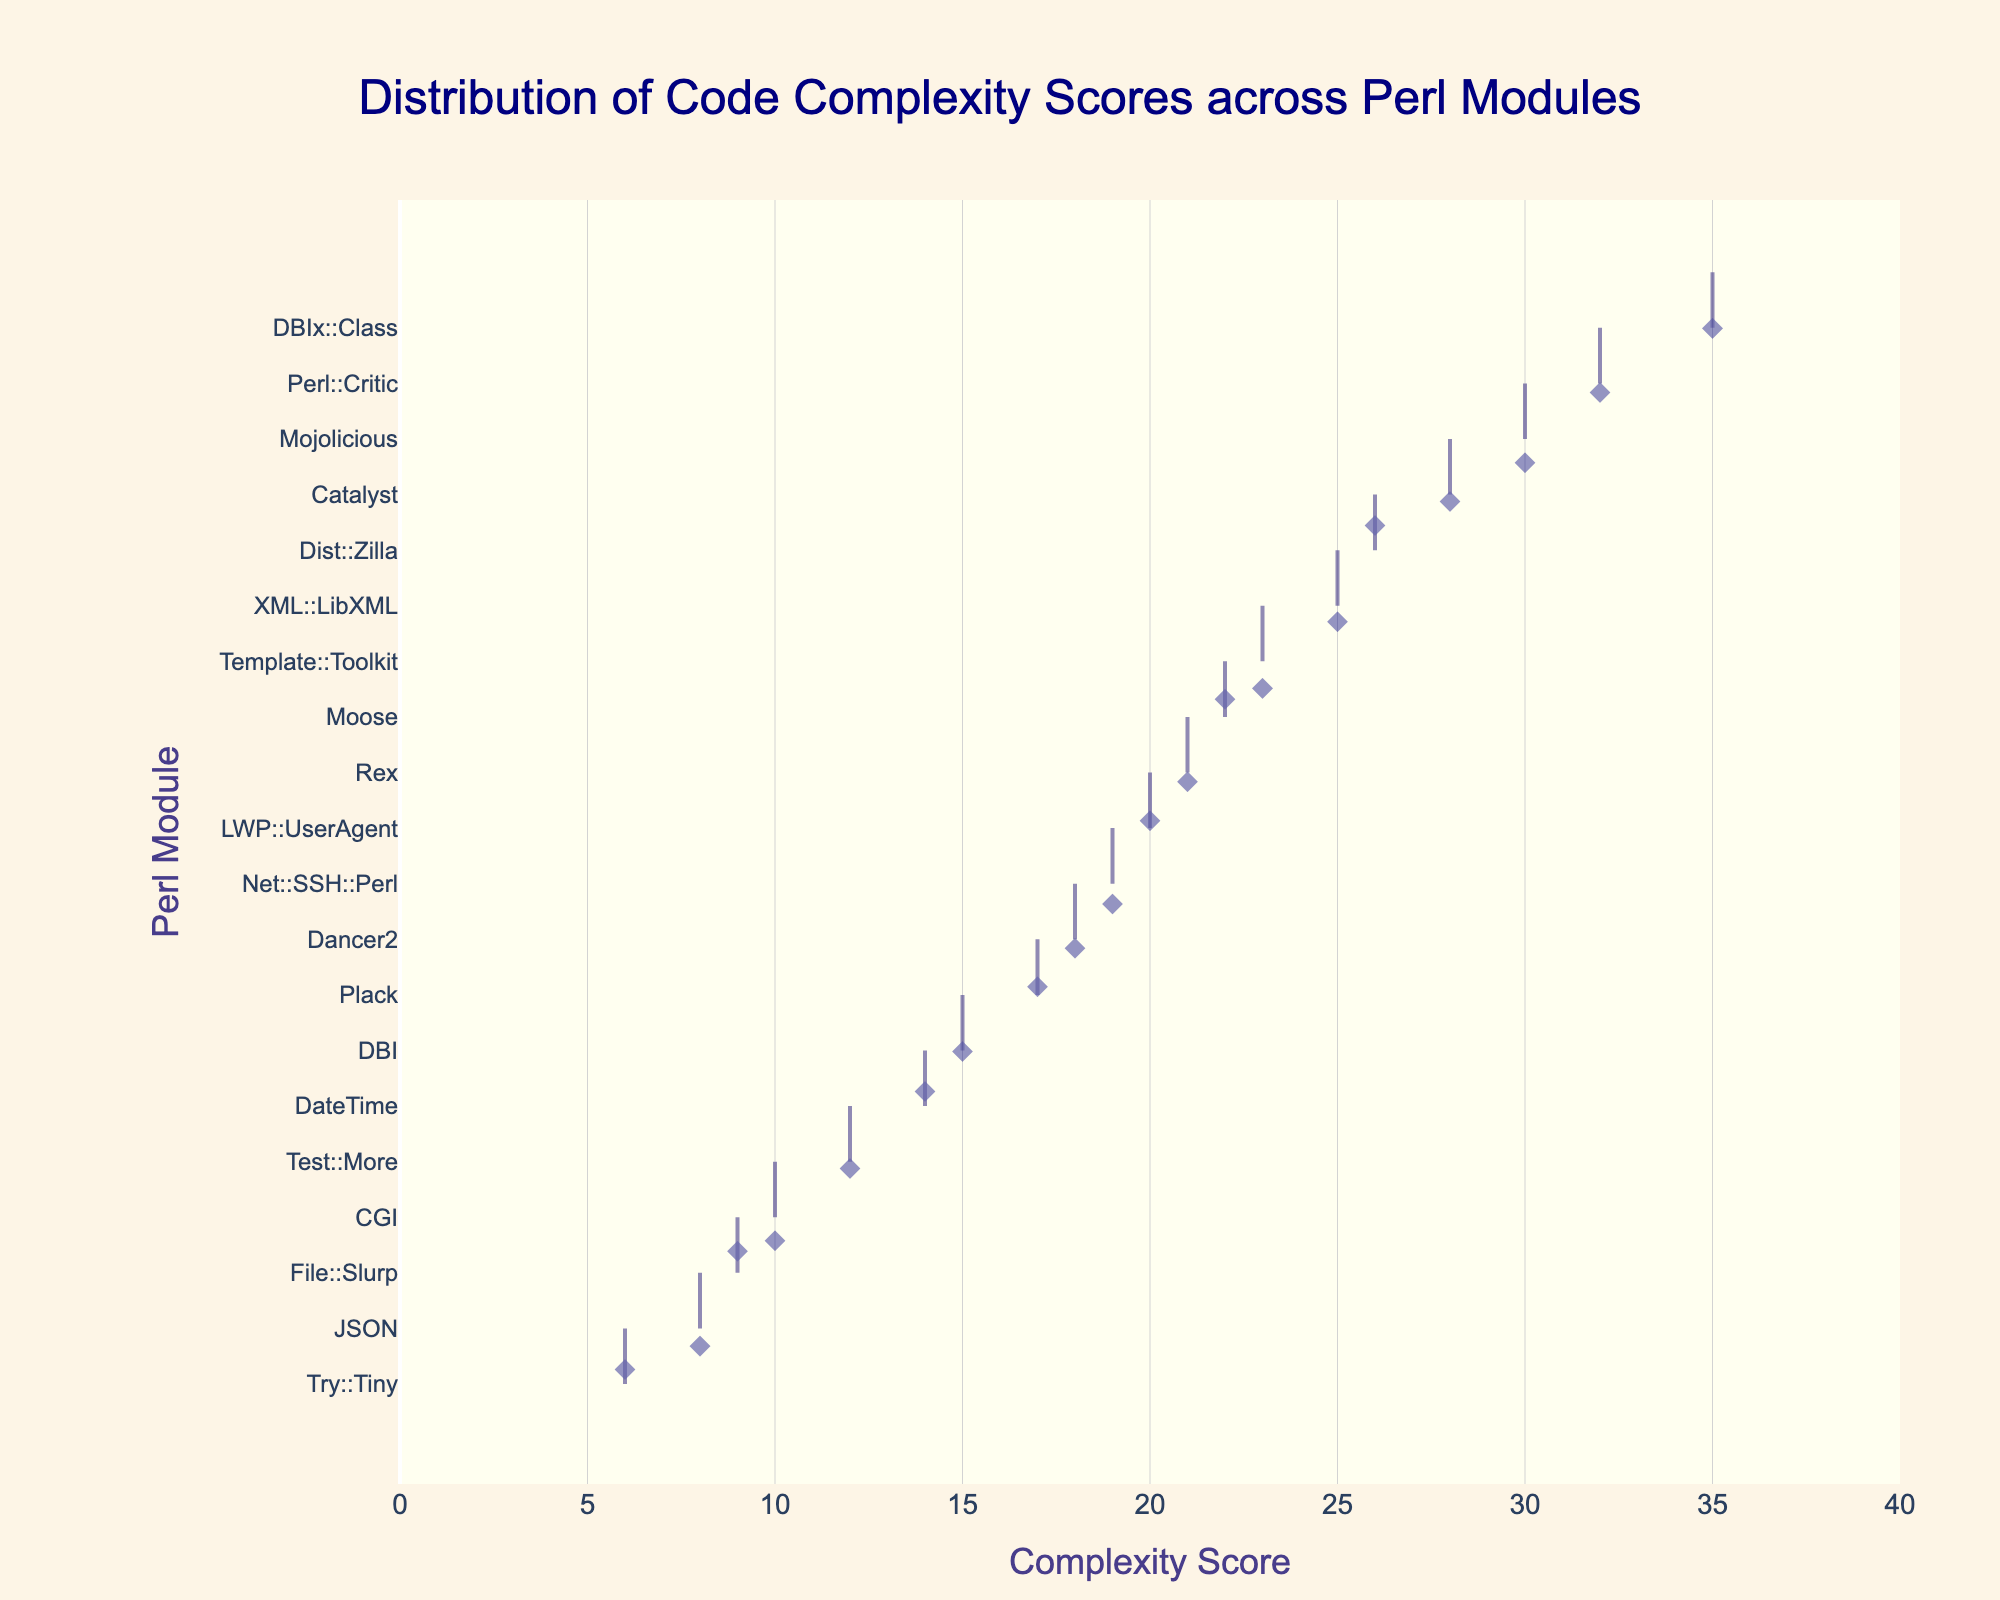What is the title of the plot? The title of the plot is usually displayed at the top of the chart. Based on the layout configurations, the title should be centered and relatively large.
Answer: Distribution of Code Complexity Scores across Perl Modules What is the highest complexity score among the Perl modules? By examining the horizontal position of the data points on the plot, the module with the highest x-coordinate represents the highest complexity score.
Answer: 35 (DBIx::Class) Which module has the lowest complexity score? The module with the lowest x-coordinate on the plot represents the lowest complexity score.
Answer: Try::Tiny How many modules have a complexity score below 15? By counting the data points that fall to the left of the vertical line at 15 on the x-axis, we can determine the number of modules below this threshold. There should be 7 such points.
Answer: 7 What's the average complexity score of the modules displayed in the plot? Sum the complexity scores of all the modules and divide by the number of modules. Calculation: (15 + 22 + 28 + 18 + 25 + 20 + 30 + 12 + 35 + 17 + 10 + 14 + 8 + 23 + 6 + 19 + 32 + 21 + 26 + 9) / 20 = 20.05
Answer: 20.05 Which modules have complexity scores between 20 and 25? Look for data points on the plot that fall between the x-coordinate lines for 20 and 25, then identify the corresponding modules on the y-axis.
Answer: DBI, Catalyst, LWP::UserAgent, Rex What range does the x-axis cover? The x-axis range is determined by the minimum and maximum scores, which is then extended slightly from 0 to just beyond the maximum score. From the code settings, it ranges from 0 to max(data['ComplexityScore']) + 5 = 40.
Answer: 0 to 40 Which module is represented by the point furthest to the right in the plot? The point furthest to the right represents the module with the highest complexity score within the distribution.
Answer: DBIx::Class Are there more modules with a complexity score above or below 20? Count the number of data points to the right (above 20) and left (below 20) of the vertical line at 20 on the plot. Above 20 we have: Moose, Catalyst, XML::LibXML, Mojolicious, DBIx::Class, Template::Toolkit, Perl::Critic, Dist::Zilla. That's 8 modules above 20 against the remaining below 20.
Answer: Below Which module has a complexity score of 30? Identify the data point with an x-coordinate of 30 and locate its corresponding y-coordinate to find the module name.
Answer: Mojolicious 